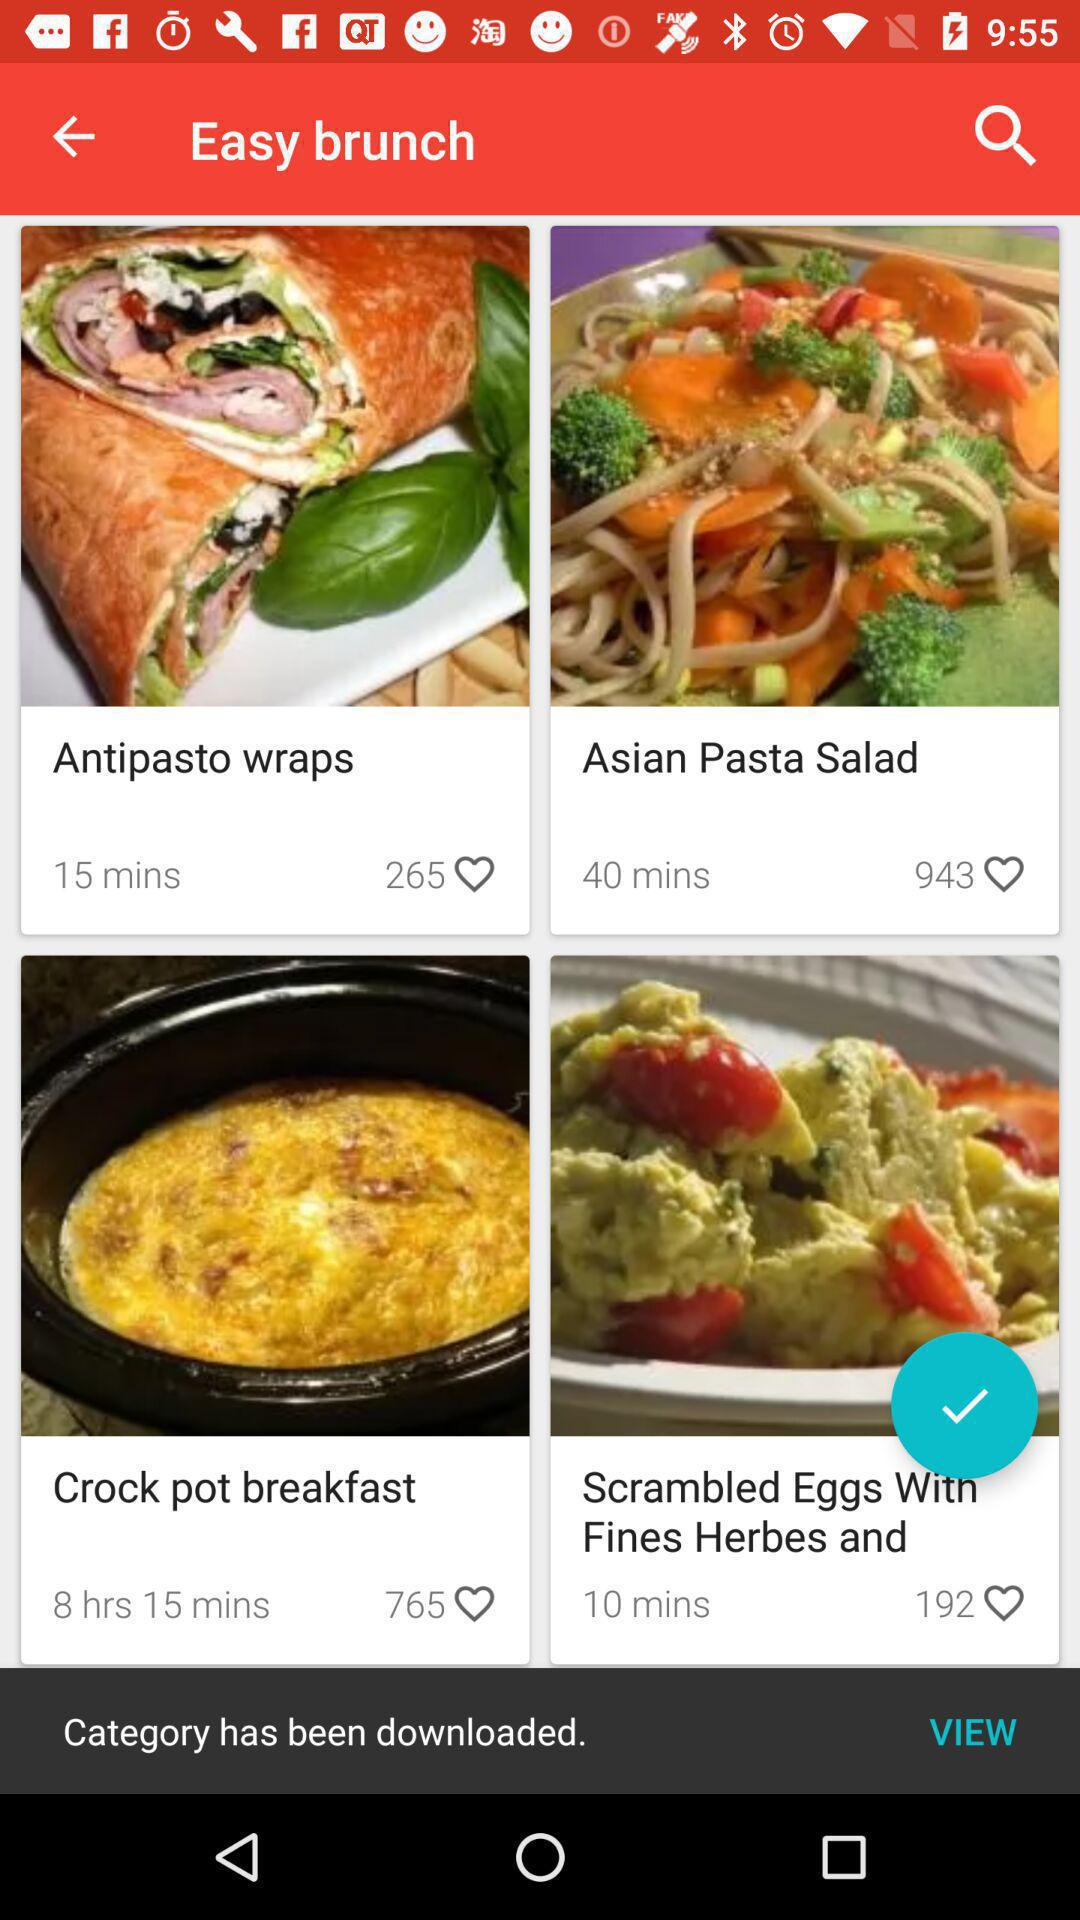How many more minutes are needed to cook the Asian Pasta Salad than the Antipasto Wraps?
Answer the question using a single word or phrase. 25 